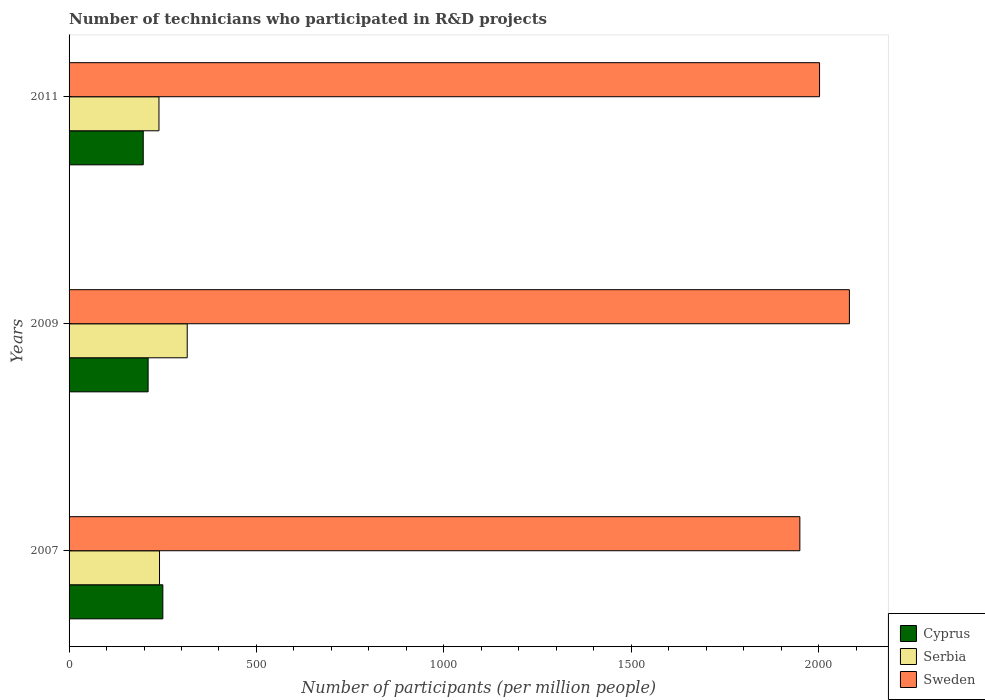How many different coloured bars are there?
Give a very brief answer. 3. How many groups of bars are there?
Your response must be concise. 3. Are the number of bars per tick equal to the number of legend labels?
Your response must be concise. Yes. Are the number of bars on each tick of the Y-axis equal?
Your answer should be very brief. Yes. What is the number of technicians who participated in R&D projects in Cyprus in 2009?
Offer a very short reply. 210.92. Across all years, what is the maximum number of technicians who participated in R&D projects in Sweden?
Provide a short and direct response. 2082.24. Across all years, what is the minimum number of technicians who participated in R&D projects in Serbia?
Provide a succinct answer. 239.9. What is the total number of technicians who participated in R&D projects in Cyprus in the graph?
Offer a terse response. 659.06. What is the difference between the number of technicians who participated in R&D projects in Serbia in 2007 and that in 2009?
Make the answer very short. -73.9. What is the difference between the number of technicians who participated in R&D projects in Serbia in 2009 and the number of technicians who participated in R&D projects in Cyprus in 2011?
Your answer should be very brief. 117.34. What is the average number of technicians who participated in R&D projects in Cyprus per year?
Make the answer very short. 219.69. In the year 2007, what is the difference between the number of technicians who participated in R&D projects in Cyprus and number of technicians who participated in R&D projects in Serbia?
Your answer should be very brief. 8.88. What is the ratio of the number of technicians who participated in R&D projects in Serbia in 2007 to that in 2011?
Your answer should be compact. 1.01. What is the difference between the highest and the second highest number of technicians who participated in R&D projects in Sweden?
Offer a terse response. 79.67. What is the difference between the highest and the lowest number of technicians who participated in R&D projects in Cyprus?
Ensure brevity in your answer.  52.31. What does the 1st bar from the bottom in 2011 represents?
Offer a terse response. Cyprus. Is it the case that in every year, the sum of the number of technicians who participated in R&D projects in Serbia and number of technicians who participated in R&D projects in Cyprus is greater than the number of technicians who participated in R&D projects in Sweden?
Keep it short and to the point. No. How many years are there in the graph?
Your answer should be very brief. 3. Does the graph contain any zero values?
Your answer should be compact. No. Does the graph contain grids?
Ensure brevity in your answer.  No. Where does the legend appear in the graph?
Give a very brief answer. Bottom right. What is the title of the graph?
Your answer should be very brief. Number of technicians who participated in R&D projects. Does "Palau" appear as one of the legend labels in the graph?
Your response must be concise. No. What is the label or title of the X-axis?
Give a very brief answer. Number of participants (per million people). What is the Number of participants (per million people) of Cyprus in 2007?
Your answer should be compact. 250.23. What is the Number of participants (per million people) of Serbia in 2007?
Your response must be concise. 241.35. What is the Number of participants (per million people) in Sweden in 2007?
Your response must be concise. 1950. What is the Number of participants (per million people) in Cyprus in 2009?
Provide a succinct answer. 210.92. What is the Number of participants (per million people) of Serbia in 2009?
Provide a succinct answer. 315.25. What is the Number of participants (per million people) in Sweden in 2009?
Give a very brief answer. 2082.24. What is the Number of participants (per million people) of Cyprus in 2011?
Your answer should be very brief. 197.91. What is the Number of participants (per million people) in Serbia in 2011?
Offer a terse response. 239.9. What is the Number of participants (per million people) of Sweden in 2011?
Offer a very short reply. 2002.57. Across all years, what is the maximum Number of participants (per million people) of Cyprus?
Your answer should be compact. 250.23. Across all years, what is the maximum Number of participants (per million people) in Serbia?
Your answer should be very brief. 315.25. Across all years, what is the maximum Number of participants (per million people) of Sweden?
Ensure brevity in your answer.  2082.24. Across all years, what is the minimum Number of participants (per million people) of Cyprus?
Offer a very short reply. 197.91. Across all years, what is the minimum Number of participants (per million people) of Serbia?
Offer a terse response. 239.9. Across all years, what is the minimum Number of participants (per million people) of Sweden?
Provide a succinct answer. 1950. What is the total Number of participants (per million people) in Cyprus in the graph?
Offer a very short reply. 659.06. What is the total Number of participants (per million people) of Serbia in the graph?
Your answer should be compact. 796.5. What is the total Number of participants (per million people) of Sweden in the graph?
Your response must be concise. 6034.81. What is the difference between the Number of participants (per million people) in Cyprus in 2007 and that in 2009?
Offer a very short reply. 39.31. What is the difference between the Number of participants (per million people) in Serbia in 2007 and that in 2009?
Ensure brevity in your answer.  -73.9. What is the difference between the Number of participants (per million people) of Sweden in 2007 and that in 2009?
Your answer should be compact. -132.24. What is the difference between the Number of participants (per million people) in Cyprus in 2007 and that in 2011?
Make the answer very short. 52.31. What is the difference between the Number of participants (per million people) in Serbia in 2007 and that in 2011?
Your answer should be compact. 1.45. What is the difference between the Number of participants (per million people) in Sweden in 2007 and that in 2011?
Offer a very short reply. -52.56. What is the difference between the Number of participants (per million people) of Cyprus in 2009 and that in 2011?
Keep it short and to the point. 13. What is the difference between the Number of participants (per million people) of Serbia in 2009 and that in 2011?
Give a very brief answer. 75.36. What is the difference between the Number of participants (per million people) of Sweden in 2009 and that in 2011?
Provide a succinct answer. 79.67. What is the difference between the Number of participants (per million people) in Cyprus in 2007 and the Number of participants (per million people) in Serbia in 2009?
Offer a terse response. -65.03. What is the difference between the Number of participants (per million people) of Cyprus in 2007 and the Number of participants (per million people) of Sweden in 2009?
Your response must be concise. -1832.02. What is the difference between the Number of participants (per million people) of Serbia in 2007 and the Number of participants (per million people) of Sweden in 2009?
Offer a very short reply. -1840.89. What is the difference between the Number of participants (per million people) in Cyprus in 2007 and the Number of participants (per million people) in Serbia in 2011?
Your response must be concise. 10.33. What is the difference between the Number of participants (per million people) in Cyprus in 2007 and the Number of participants (per million people) in Sweden in 2011?
Provide a succinct answer. -1752.34. What is the difference between the Number of participants (per million people) in Serbia in 2007 and the Number of participants (per million people) in Sweden in 2011?
Offer a very short reply. -1761.22. What is the difference between the Number of participants (per million people) of Cyprus in 2009 and the Number of participants (per million people) of Serbia in 2011?
Your answer should be compact. -28.98. What is the difference between the Number of participants (per million people) of Cyprus in 2009 and the Number of participants (per million people) of Sweden in 2011?
Your answer should be very brief. -1791.65. What is the difference between the Number of participants (per million people) in Serbia in 2009 and the Number of participants (per million people) in Sweden in 2011?
Offer a very short reply. -1687.32. What is the average Number of participants (per million people) of Cyprus per year?
Provide a short and direct response. 219.69. What is the average Number of participants (per million people) of Serbia per year?
Provide a short and direct response. 265.5. What is the average Number of participants (per million people) in Sweden per year?
Your answer should be compact. 2011.6. In the year 2007, what is the difference between the Number of participants (per million people) in Cyprus and Number of participants (per million people) in Serbia?
Provide a short and direct response. 8.88. In the year 2007, what is the difference between the Number of participants (per million people) of Cyprus and Number of participants (per million people) of Sweden?
Make the answer very short. -1699.78. In the year 2007, what is the difference between the Number of participants (per million people) in Serbia and Number of participants (per million people) in Sweden?
Keep it short and to the point. -1708.65. In the year 2009, what is the difference between the Number of participants (per million people) of Cyprus and Number of participants (per million people) of Serbia?
Your answer should be compact. -104.34. In the year 2009, what is the difference between the Number of participants (per million people) of Cyprus and Number of participants (per million people) of Sweden?
Offer a very short reply. -1871.33. In the year 2009, what is the difference between the Number of participants (per million people) in Serbia and Number of participants (per million people) in Sweden?
Your answer should be very brief. -1766.99. In the year 2011, what is the difference between the Number of participants (per million people) of Cyprus and Number of participants (per million people) of Serbia?
Give a very brief answer. -41.98. In the year 2011, what is the difference between the Number of participants (per million people) of Cyprus and Number of participants (per million people) of Sweden?
Provide a short and direct response. -1804.65. In the year 2011, what is the difference between the Number of participants (per million people) in Serbia and Number of participants (per million people) in Sweden?
Offer a terse response. -1762.67. What is the ratio of the Number of participants (per million people) in Cyprus in 2007 to that in 2009?
Keep it short and to the point. 1.19. What is the ratio of the Number of participants (per million people) in Serbia in 2007 to that in 2009?
Give a very brief answer. 0.77. What is the ratio of the Number of participants (per million people) in Sweden in 2007 to that in 2009?
Ensure brevity in your answer.  0.94. What is the ratio of the Number of participants (per million people) of Cyprus in 2007 to that in 2011?
Keep it short and to the point. 1.26. What is the ratio of the Number of participants (per million people) of Serbia in 2007 to that in 2011?
Provide a succinct answer. 1.01. What is the ratio of the Number of participants (per million people) in Sweden in 2007 to that in 2011?
Your response must be concise. 0.97. What is the ratio of the Number of participants (per million people) of Cyprus in 2009 to that in 2011?
Keep it short and to the point. 1.07. What is the ratio of the Number of participants (per million people) in Serbia in 2009 to that in 2011?
Keep it short and to the point. 1.31. What is the ratio of the Number of participants (per million people) of Sweden in 2009 to that in 2011?
Keep it short and to the point. 1.04. What is the difference between the highest and the second highest Number of participants (per million people) of Cyprus?
Offer a terse response. 39.31. What is the difference between the highest and the second highest Number of participants (per million people) in Serbia?
Your answer should be compact. 73.9. What is the difference between the highest and the second highest Number of participants (per million people) of Sweden?
Offer a terse response. 79.67. What is the difference between the highest and the lowest Number of participants (per million people) of Cyprus?
Offer a very short reply. 52.31. What is the difference between the highest and the lowest Number of participants (per million people) of Serbia?
Offer a terse response. 75.36. What is the difference between the highest and the lowest Number of participants (per million people) of Sweden?
Offer a very short reply. 132.24. 